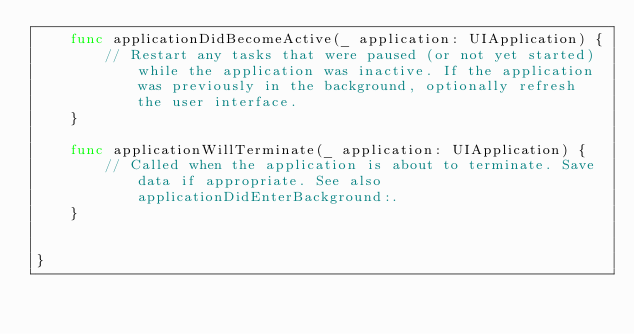Convert code to text. <code><loc_0><loc_0><loc_500><loc_500><_Swift_>    func applicationDidBecomeActive(_ application: UIApplication) {
        // Restart any tasks that were paused (or not yet started) while the application was inactive. If the application was previously in the background, optionally refresh the user interface.
    }

    func applicationWillTerminate(_ application: UIApplication) {
        // Called when the application is about to terminate. Save data if appropriate. See also applicationDidEnterBackground:.
    }


}

</code> 